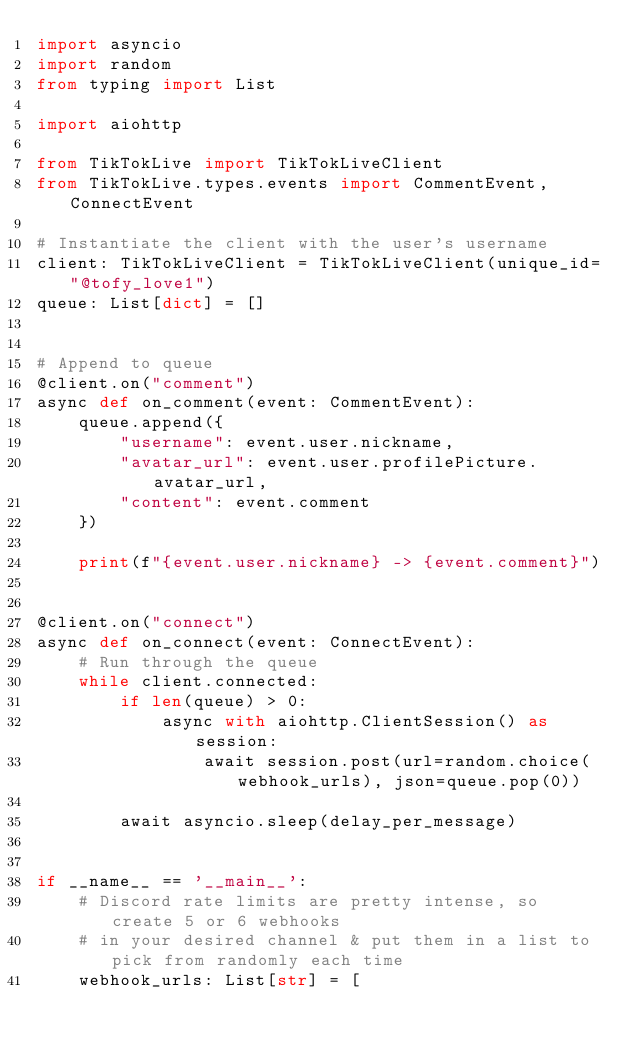Convert code to text. <code><loc_0><loc_0><loc_500><loc_500><_Python_>import asyncio
import random
from typing import List

import aiohttp

from TikTokLive import TikTokLiveClient
from TikTokLive.types.events import CommentEvent, ConnectEvent

# Instantiate the client with the user's username
client: TikTokLiveClient = TikTokLiveClient(unique_id="@tofy_love1")
queue: List[dict] = []


# Append to queue
@client.on("comment")
async def on_comment(event: CommentEvent):
    queue.append({
        "username": event.user.nickname,
        "avatar_url": event.user.profilePicture.avatar_url,
        "content": event.comment
    })

    print(f"{event.user.nickname} -> {event.comment}")


@client.on("connect")
async def on_connect(event: ConnectEvent):
    # Run through the queue
    while client.connected:
        if len(queue) > 0:
            async with aiohttp.ClientSession() as session:
                await session.post(url=random.choice(webhook_urls), json=queue.pop(0))

        await asyncio.sleep(delay_per_message)


if __name__ == '__main__':
    # Discord rate limits are pretty intense, so create 5 or 6 webhooks
    # in your desired channel & put them in a list to pick from randomly each time
    webhook_urls: List[str] = [</code> 